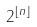Convert formula to latex. <formula><loc_0><loc_0><loc_500><loc_500>2 ^ { \lfloor n \rfloor }</formula> 